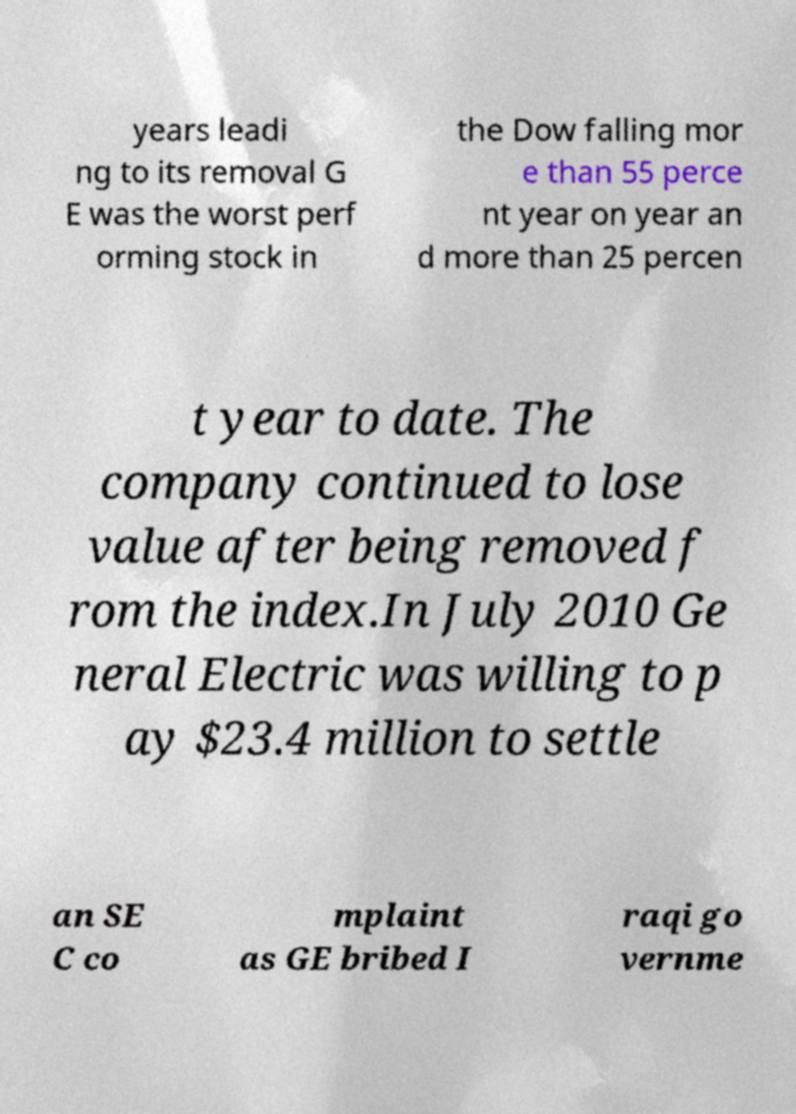What messages or text are displayed in this image? I need them in a readable, typed format. years leadi ng to its removal G E was the worst perf orming stock in the Dow falling mor e than 55 perce nt year on year an d more than 25 percen t year to date. The company continued to lose value after being removed f rom the index.In July 2010 Ge neral Electric was willing to p ay $23.4 million to settle an SE C co mplaint as GE bribed I raqi go vernme 